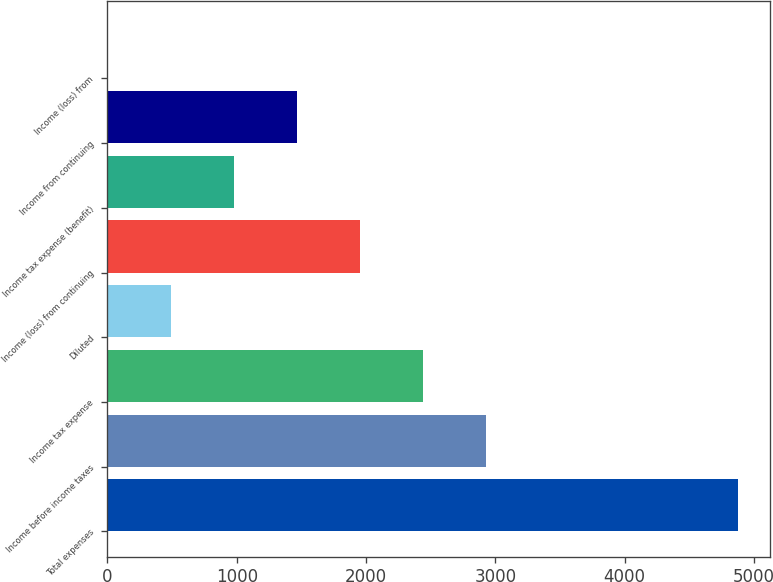Convert chart. <chart><loc_0><loc_0><loc_500><loc_500><bar_chart><fcel>Total expenses<fcel>Income before income taxes<fcel>Income tax expense<fcel>Diluted<fcel>Income (loss) from continuing<fcel>Income tax expense (benefit)<fcel>Income from continuing<fcel>Income (loss) from<nl><fcel>4880<fcel>2928.4<fcel>2440.5<fcel>488.9<fcel>1952.6<fcel>976.8<fcel>1464.7<fcel>1<nl></chart> 